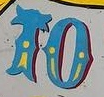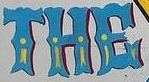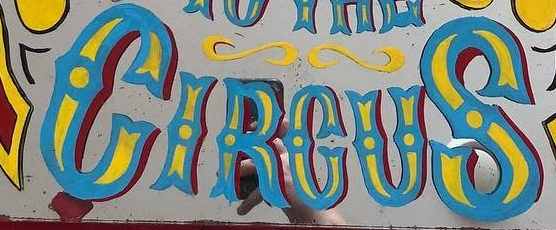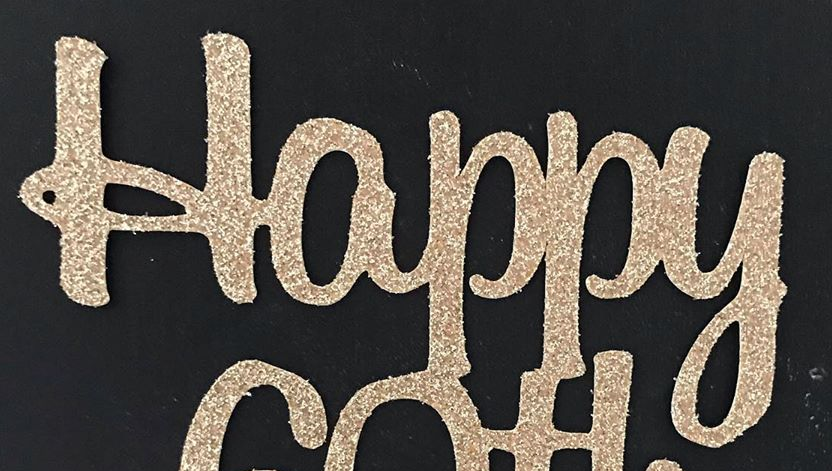Read the text content from these images in order, separated by a semicolon. TO; THE; CIRCUS; Happy 